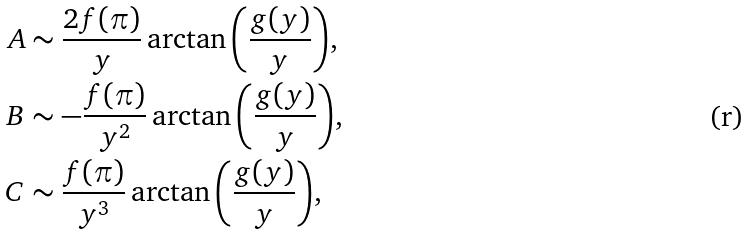<formula> <loc_0><loc_0><loc_500><loc_500>A & \sim \frac { 2 f ( \pi ) } { y } \arctan { \left ( \frac { g ( y ) } { y } \right ) } , \\ B & \sim - \frac { f ( \pi ) } { y ^ { 2 } } \arctan { \left ( \frac { g ( y ) } { y } \right ) } , \\ C & \sim \frac { f ( \pi ) } { y ^ { 3 } } \arctan { \left ( \frac { g ( y ) } { y } \right ) } , \\</formula> 